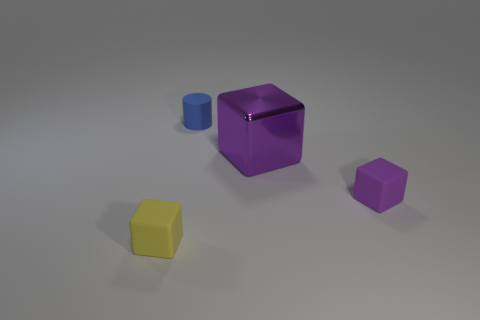How many other objects are the same shape as the blue rubber thing?
Make the answer very short. 0. Is the number of yellow rubber things greater than the number of things?
Provide a short and direct response. No. There is a cube behind the small purple cube that is on the right side of the rubber cube that is on the left side of the tiny purple cube; what is its size?
Provide a succinct answer. Large. How big is the matte object that is right of the small blue cylinder?
Make the answer very short. Small. What number of objects are tiny purple matte objects or small matte things that are on the right side of the tiny blue cylinder?
Provide a succinct answer. 1. What number of other objects are the same size as the purple rubber cube?
Provide a short and direct response. 2. There is a yellow object that is the same shape as the purple matte thing; what is its material?
Provide a short and direct response. Rubber. Are there more things that are in front of the tiny purple thing than big brown metallic spheres?
Your answer should be very brief. Yes. Is there anything else of the same color as the cylinder?
Your answer should be very brief. No. What is the shape of the purple object that is made of the same material as the small yellow object?
Your answer should be compact. Cube. 